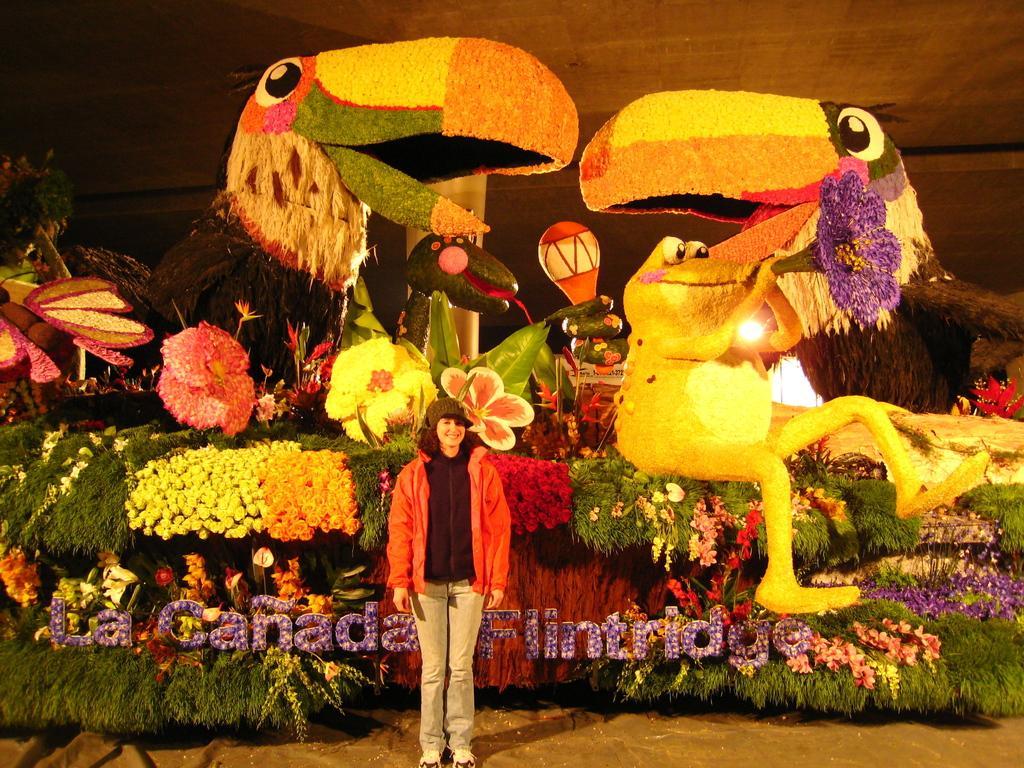Could you give a brief overview of what you see in this image? In this image we can see a woman standing on the ground wearing orange coat and the cap. In the background we can see group of flowers ,leaves are carved in the shape of some animals. 